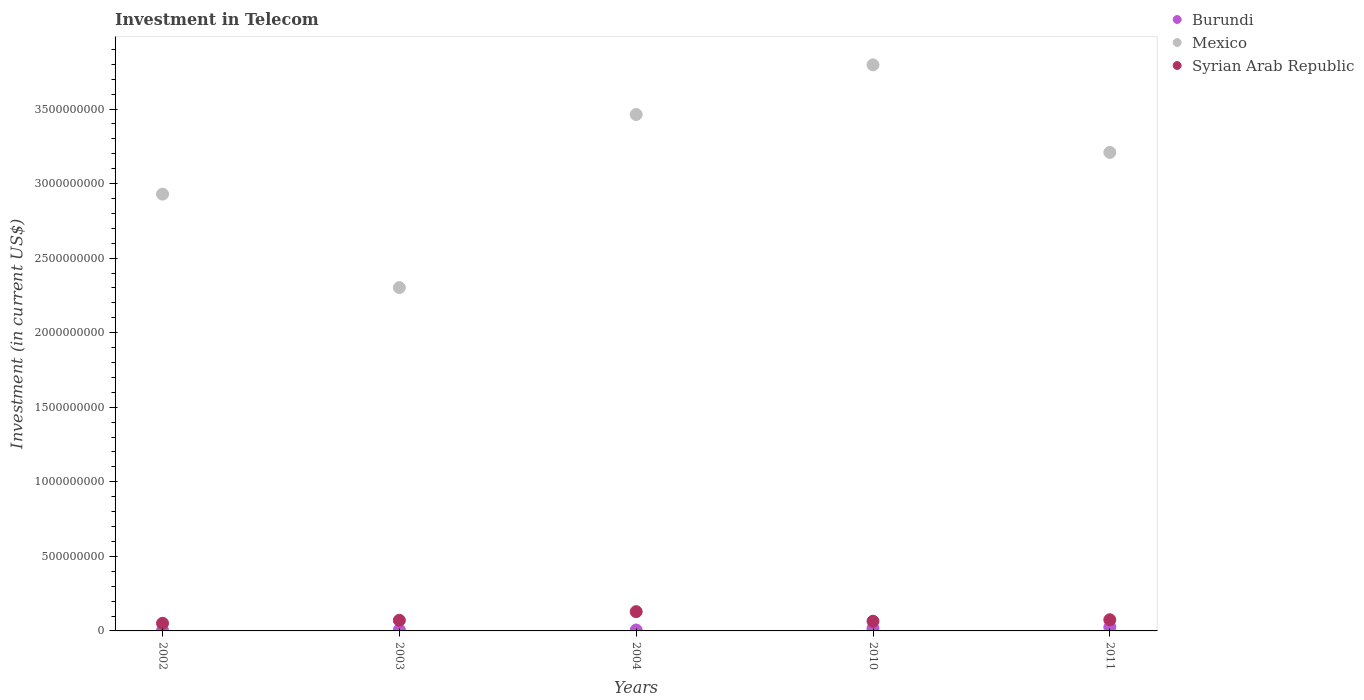Is the number of dotlines equal to the number of legend labels?
Your response must be concise. Yes. What is the amount invested in telecom in Burundi in 2010?
Make the answer very short. 1.70e+07. Across all years, what is the maximum amount invested in telecom in Syrian Arab Republic?
Offer a terse response. 1.29e+08. Across all years, what is the minimum amount invested in telecom in Mexico?
Make the answer very short. 2.30e+09. In which year was the amount invested in telecom in Syrian Arab Republic maximum?
Keep it short and to the point. 2004. In which year was the amount invested in telecom in Mexico minimum?
Offer a very short reply. 2003. What is the total amount invested in telecom in Mexico in the graph?
Make the answer very short. 1.57e+1. What is the difference between the amount invested in telecom in Burundi in 2004 and that in 2011?
Keep it short and to the point. -1.90e+07. What is the difference between the amount invested in telecom in Syrian Arab Republic in 2004 and the amount invested in telecom in Burundi in 2010?
Provide a short and direct response. 1.12e+08. What is the average amount invested in telecom in Syrian Arab Republic per year?
Offer a terse response. 7.84e+07. In the year 2004, what is the difference between the amount invested in telecom in Burundi and amount invested in telecom in Syrian Arab Republic?
Give a very brief answer. -1.23e+08. What is the ratio of the amount invested in telecom in Burundi in 2004 to that in 2010?
Provide a short and direct response. 0.35. Is the amount invested in telecom in Burundi in 2002 less than that in 2011?
Offer a terse response. Yes. What is the difference between the highest and the second highest amount invested in telecom in Burundi?
Your answer should be compact. 8.00e+06. What is the difference between the highest and the lowest amount invested in telecom in Mexico?
Offer a very short reply. 1.49e+09. In how many years, is the amount invested in telecom in Burundi greater than the average amount invested in telecom in Burundi taken over all years?
Offer a terse response. 2. Is the sum of the amount invested in telecom in Syrian Arab Republic in 2002 and 2010 greater than the maximum amount invested in telecom in Burundi across all years?
Your answer should be very brief. Yes. Is it the case that in every year, the sum of the amount invested in telecom in Syrian Arab Republic and amount invested in telecom in Mexico  is greater than the amount invested in telecom in Burundi?
Keep it short and to the point. Yes. Does the amount invested in telecom in Syrian Arab Republic monotonically increase over the years?
Provide a succinct answer. No. Is the amount invested in telecom in Mexico strictly less than the amount invested in telecom in Burundi over the years?
Offer a terse response. No. How many years are there in the graph?
Provide a succinct answer. 5. What is the difference between two consecutive major ticks on the Y-axis?
Offer a terse response. 5.00e+08. Where does the legend appear in the graph?
Ensure brevity in your answer.  Top right. How many legend labels are there?
Make the answer very short. 3. How are the legend labels stacked?
Offer a very short reply. Vertical. What is the title of the graph?
Provide a succinct answer. Investment in Telecom. What is the label or title of the X-axis?
Offer a very short reply. Years. What is the label or title of the Y-axis?
Make the answer very short. Investment (in current US$). What is the Investment (in current US$) of Mexico in 2002?
Your response must be concise. 2.93e+09. What is the Investment (in current US$) of Syrian Arab Republic in 2002?
Provide a succinct answer. 5.12e+07. What is the Investment (in current US$) in Burundi in 2003?
Make the answer very short. 6.00e+06. What is the Investment (in current US$) of Mexico in 2003?
Keep it short and to the point. 2.30e+09. What is the Investment (in current US$) in Syrian Arab Republic in 2003?
Give a very brief answer. 7.12e+07. What is the Investment (in current US$) of Mexico in 2004?
Your response must be concise. 3.46e+09. What is the Investment (in current US$) of Syrian Arab Republic in 2004?
Offer a very short reply. 1.29e+08. What is the Investment (in current US$) of Burundi in 2010?
Offer a very short reply. 1.70e+07. What is the Investment (in current US$) of Mexico in 2010?
Make the answer very short. 3.80e+09. What is the Investment (in current US$) of Syrian Arab Republic in 2010?
Offer a terse response. 6.50e+07. What is the Investment (in current US$) in Burundi in 2011?
Offer a terse response. 2.50e+07. What is the Investment (in current US$) in Mexico in 2011?
Give a very brief answer. 3.21e+09. What is the Investment (in current US$) of Syrian Arab Republic in 2011?
Provide a short and direct response. 7.50e+07. Across all years, what is the maximum Investment (in current US$) in Burundi?
Provide a succinct answer. 2.50e+07. Across all years, what is the maximum Investment (in current US$) of Mexico?
Your answer should be very brief. 3.80e+09. Across all years, what is the maximum Investment (in current US$) in Syrian Arab Republic?
Provide a short and direct response. 1.29e+08. Across all years, what is the minimum Investment (in current US$) of Mexico?
Give a very brief answer. 2.30e+09. Across all years, what is the minimum Investment (in current US$) in Syrian Arab Republic?
Offer a terse response. 5.12e+07. What is the total Investment (in current US$) in Burundi in the graph?
Your answer should be very brief. 5.70e+07. What is the total Investment (in current US$) of Mexico in the graph?
Offer a very short reply. 1.57e+1. What is the total Investment (in current US$) of Syrian Arab Republic in the graph?
Your answer should be compact. 3.92e+08. What is the difference between the Investment (in current US$) in Burundi in 2002 and that in 2003?
Make the answer very short. -3.00e+06. What is the difference between the Investment (in current US$) of Mexico in 2002 and that in 2003?
Offer a very short reply. 6.27e+08. What is the difference between the Investment (in current US$) of Syrian Arab Republic in 2002 and that in 2003?
Offer a very short reply. -2.00e+07. What is the difference between the Investment (in current US$) of Mexico in 2002 and that in 2004?
Make the answer very short. -5.34e+08. What is the difference between the Investment (in current US$) of Syrian Arab Republic in 2002 and that in 2004?
Offer a terse response. -7.80e+07. What is the difference between the Investment (in current US$) of Burundi in 2002 and that in 2010?
Ensure brevity in your answer.  -1.40e+07. What is the difference between the Investment (in current US$) in Mexico in 2002 and that in 2010?
Your response must be concise. -8.67e+08. What is the difference between the Investment (in current US$) in Syrian Arab Republic in 2002 and that in 2010?
Your answer should be compact. -1.38e+07. What is the difference between the Investment (in current US$) in Burundi in 2002 and that in 2011?
Ensure brevity in your answer.  -2.20e+07. What is the difference between the Investment (in current US$) in Mexico in 2002 and that in 2011?
Provide a succinct answer. -2.80e+08. What is the difference between the Investment (in current US$) of Syrian Arab Republic in 2002 and that in 2011?
Your response must be concise. -2.38e+07. What is the difference between the Investment (in current US$) in Burundi in 2003 and that in 2004?
Offer a very short reply. 0. What is the difference between the Investment (in current US$) in Mexico in 2003 and that in 2004?
Provide a succinct answer. -1.16e+09. What is the difference between the Investment (in current US$) in Syrian Arab Republic in 2003 and that in 2004?
Offer a terse response. -5.80e+07. What is the difference between the Investment (in current US$) in Burundi in 2003 and that in 2010?
Provide a short and direct response. -1.10e+07. What is the difference between the Investment (in current US$) of Mexico in 2003 and that in 2010?
Ensure brevity in your answer.  -1.49e+09. What is the difference between the Investment (in current US$) in Syrian Arab Republic in 2003 and that in 2010?
Provide a short and direct response. 6.25e+06. What is the difference between the Investment (in current US$) of Burundi in 2003 and that in 2011?
Your response must be concise. -1.90e+07. What is the difference between the Investment (in current US$) of Mexico in 2003 and that in 2011?
Offer a very short reply. -9.06e+08. What is the difference between the Investment (in current US$) of Syrian Arab Republic in 2003 and that in 2011?
Your answer should be very brief. -3.75e+06. What is the difference between the Investment (in current US$) in Burundi in 2004 and that in 2010?
Offer a very short reply. -1.10e+07. What is the difference between the Investment (in current US$) of Mexico in 2004 and that in 2010?
Your answer should be very brief. -3.33e+08. What is the difference between the Investment (in current US$) in Syrian Arab Republic in 2004 and that in 2010?
Offer a very short reply. 6.42e+07. What is the difference between the Investment (in current US$) of Burundi in 2004 and that in 2011?
Give a very brief answer. -1.90e+07. What is the difference between the Investment (in current US$) of Mexico in 2004 and that in 2011?
Provide a short and direct response. 2.54e+08. What is the difference between the Investment (in current US$) in Syrian Arab Republic in 2004 and that in 2011?
Give a very brief answer. 5.42e+07. What is the difference between the Investment (in current US$) in Burundi in 2010 and that in 2011?
Offer a very short reply. -8.00e+06. What is the difference between the Investment (in current US$) of Mexico in 2010 and that in 2011?
Give a very brief answer. 5.87e+08. What is the difference between the Investment (in current US$) in Syrian Arab Republic in 2010 and that in 2011?
Provide a succinct answer. -1.00e+07. What is the difference between the Investment (in current US$) of Burundi in 2002 and the Investment (in current US$) of Mexico in 2003?
Provide a short and direct response. -2.30e+09. What is the difference between the Investment (in current US$) in Burundi in 2002 and the Investment (in current US$) in Syrian Arab Republic in 2003?
Provide a succinct answer. -6.82e+07. What is the difference between the Investment (in current US$) in Mexico in 2002 and the Investment (in current US$) in Syrian Arab Republic in 2003?
Offer a terse response. 2.86e+09. What is the difference between the Investment (in current US$) of Burundi in 2002 and the Investment (in current US$) of Mexico in 2004?
Provide a succinct answer. -3.46e+09. What is the difference between the Investment (in current US$) in Burundi in 2002 and the Investment (in current US$) in Syrian Arab Republic in 2004?
Give a very brief answer. -1.26e+08. What is the difference between the Investment (in current US$) in Mexico in 2002 and the Investment (in current US$) in Syrian Arab Republic in 2004?
Ensure brevity in your answer.  2.80e+09. What is the difference between the Investment (in current US$) of Burundi in 2002 and the Investment (in current US$) of Mexico in 2010?
Your answer should be compact. -3.79e+09. What is the difference between the Investment (in current US$) in Burundi in 2002 and the Investment (in current US$) in Syrian Arab Republic in 2010?
Keep it short and to the point. -6.20e+07. What is the difference between the Investment (in current US$) of Mexico in 2002 and the Investment (in current US$) of Syrian Arab Republic in 2010?
Your answer should be compact. 2.86e+09. What is the difference between the Investment (in current US$) of Burundi in 2002 and the Investment (in current US$) of Mexico in 2011?
Keep it short and to the point. -3.21e+09. What is the difference between the Investment (in current US$) of Burundi in 2002 and the Investment (in current US$) of Syrian Arab Republic in 2011?
Offer a terse response. -7.20e+07. What is the difference between the Investment (in current US$) in Mexico in 2002 and the Investment (in current US$) in Syrian Arab Republic in 2011?
Offer a terse response. 2.85e+09. What is the difference between the Investment (in current US$) of Burundi in 2003 and the Investment (in current US$) of Mexico in 2004?
Make the answer very short. -3.46e+09. What is the difference between the Investment (in current US$) in Burundi in 2003 and the Investment (in current US$) in Syrian Arab Republic in 2004?
Offer a very short reply. -1.23e+08. What is the difference between the Investment (in current US$) of Mexico in 2003 and the Investment (in current US$) of Syrian Arab Republic in 2004?
Your answer should be compact. 2.17e+09. What is the difference between the Investment (in current US$) of Burundi in 2003 and the Investment (in current US$) of Mexico in 2010?
Your answer should be very brief. -3.79e+09. What is the difference between the Investment (in current US$) in Burundi in 2003 and the Investment (in current US$) in Syrian Arab Republic in 2010?
Your answer should be very brief. -5.90e+07. What is the difference between the Investment (in current US$) of Mexico in 2003 and the Investment (in current US$) of Syrian Arab Republic in 2010?
Offer a terse response. 2.24e+09. What is the difference between the Investment (in current US$) of Burundi in 2003 and the Investment (in current US$) of Mexico in 2011?
Offer a very short reply. -3.20e+09. What is the difference between the Investment (in current US$) in Burundi in 2003 and the Investment (in current US$) in Syrian Arab Republic in 2011?
Keep it short and to the point. -6.90e+07. What is the difference between the Investment (in current US$) of Mexico in 2003 and the Investment (in current US$) of Syrian Arab Republic in 2011?
Your answer should be compact. 2.23e+09. What is the difference between the Investment (in current US$) in Burundi in 2004 and the Investment (in current US$) in Mexico in 2010?
Keep it short and to the point. -3.79e+09. What is the difference between the Investment (in current US$) of Burundi in 2004 and the Investment (in current US$) of Syrian Arab Republic in 2010?
Your answer should be compact. -5.90e+07. What is the difference between the Investment (in current US$) in Mexico in 2004 and the Investment (in current US$) in Syrian Arab Republic in 2010?
Your answer should be very brief. 3.40e+09. What is the difference between the Investment (in current US$) in Burundi in 2004 and the Investment (in current US$) in Mexico in 2011?
Provide a succinct answer. -3.20e+09. What is the difference between the Investment (in current US$) of Burundi in 2004 and the Investment (in current US$) of Syrian Arab Republic in 2011?
Ensure brevity in your answer.  -6.90e+07. What is the difference between the Investment (in current US$) in Mexico in 2004 and the Investment (in current US$) in Syrian Arab Republic in 2011?
Give a very brief answer. 3.39e+09. What is the difference between the Investment (in current US$) of Burundi in 2010 and the Investment (in current US$) of Mexico in 2011?
Make the answer very short. -3.19e+09. What is the difference between the Investment (in current US$) of Burundi in 2010 and the Investment (in current US$) of Syrian Arab Republic in 2011?
Provide a short and direct response. -5.80e+07. What is the difference between the Investment (in current US$) of Mexico in 2010 and the Investment (in current US$) of Syrian Arab Republic in 2011?
Offer a very short reply. 3.72e+09. What is the average Investment (in current US$) in Burundi per year?
Your answer should be very brief. 1.14e+07. What is the average Investment (in current US$) of Mexico per year?
Your answer should be very brief. 3.14e+09. What is the average Investment (in current US$) in Syrian Arab Republic per year?
Offer a terse response. 7.84e+07. In the year 2002, what is the difference between the Investment (in current US$) of Burundi and Investment (in current US$) of Mexico?
Offer a terse response. -2.93e+09. In the year 2002, what is the difference between the Investment (in current US$) of Burundi and Investment (in current US$) of Syrian Arab Republic?
Provide a short and direct response. -4.82e+07. In the year 2002, what is the difference between the Investment (in current US$) of Mexico and Investment (in current US$) of Syrian Arab Republic?
Keep it short and to the point. 2.88e+09. In the year 2003, what is the difference between the Investment (in current US$) of Burundi and Investment (in current US$) of Mexico?
Ensure brevity in your answer.  -2.30e+09. In the year 2003, what is the difference between the Investment (in current US$) in Burundi and Investment (in current US$) in Syrian Arab Republic?
Provide a succinct answer. -6.52e+07. In the year 2003, what is the difference between the Investment (in current US$) of Mexico and Investment (in current US$) of Syrian Arab Republic?
Your answer should be compact. 2.23e+09. In the year 2004, what is the difference between the Investment (in current US$) in Burundi and Investment (in current US$) in Mexico?
Provide a succinct answer. -3.46e+09. In the year 2004, what is the difference between the Investment (in current US$) of Burundi and Investment (in current US$) of Syrian Arab Republic?
Keep it short and to the point. -1.23e+08. In the year 2004, what is the difference between the Investment (in current US$) of Mexico and Investment (in current US$) of Syrian Arab Republic?
Ensure brevity in your answer.  3.33e+09. In the year 2010, what is the difference between the Investment (in current US$) in Burundi and Investment (in current US$) in Mexico?
Make the answer very short. -3.78e+09. In the year 2010, what is the difference between the Investment (in current US$) in Burundi and Investment (in current US$) in Syrian Arab Republic?
Ensure brevity in your answer.  -4.80e+07. In the year 2010, what is the difference between the Investment (in current US$) in Mexico and Investment (in current US$) in Syrian Arab Republic?
Make the answer very short. 3.73e+09. In the year 2011, what is the difference between the Investment (in current US$) of Burundi and Investment (in current US$) of Mexico?
Your answer should be compact. -3.18e+09. In the year 2011, what is the difference between the Investment (in current US$) in Burundi and Investment (in current US$) in Syrian Arab Republic?
Keep it short and to the point. -5.00e+07. In the year 2011, what is the difference between the Investment (in current US$) in Mexico and Investment (in current US$) in Syrian Arab Republic?
Provide a short and direct response. 3.13e+09. What is the ratio of the Investment (in current US$) in Burundi in 2002 to that in 2003?
Make the answer very short. 0.5. What is the ratio of the Investment (in current US$) of Mexico in 2002 to that in 2003?
Give a very brief answer. 1.27. What is the ratio of the Investment (in current US$) in Syrian Arab Republic in 2002 to that in 2003?
Provide a succinct answer. 0.72. What is the ratio of the Investment (in current US$) of Mexico in 2002 to that in 2004?
Your response must be concise. 0.85. What is the ratio of the Investment (in current US$) of Syrian Arab Republic in 2002 to that in 2004?
Keep it short and to the point. 0.4. What is the ratio of the Investment (in current US$) of Burundi in 2002 to that in 2010?
Make the answer very short. 0.18. What is the ratio of the Investment (in current US$) in Mexico in 2002 to that in 2010?
Make the answer very short. 0.77. What is the ratio of the Investment (in current US$) in Syrian Arab Republic in 2002 to that in 2010?
Your answer should be very brief. 0.79. What is the ratio of the Investment (in current US$) of Burundi in 2002 to that in 2011?
Keep it short and to the point. 0.12. What is the ratio of the Investment (in current US$) of Mexico in 2002 to that in 2011?
Keep it short and to the point. 0.91. What is the ratio of the Investment (in current US$) of Syrian Arab Republic in 2002 to that in 2011?
Give a very brief answer. 0.68. What is the ratio of the Investment (in current US$) in Burundi in 2003 to that in 2004?
Provide a succinct answer. 1. What is the ratio of the Investment (in current US$) in Mexico in 2003 to that in 2004?
Your answer should be very brief. 0.66. What is the ratio of the Investment (in current US$) of Syrian Arab Republic in 2003 to that in 2004?
Ensure brevity in your answer.  0.55. What is the ratio of the Investment (in current US$) of Burundi in 2003 to that in 2010?
Provide a short and direct response. 0.35. What is the ratio of the Investment (in current US$) in Mexico in 2003 to that in 2010?
Ensure brevity in your answer.  0.61. What is the ratio of the Investment (in current US$) of Syrian Arab Republic in 2003 to that in 2010?
Your answer should be compact. 1.1. What is the ratio of the Investment (in current US$) in Burundi in 2003 to that in 2011?
Your answer should be compact. 0.24. What is the ratio of the Investment (in current US$) of Mexico in 2003 to that in 2011?
Provide a succinct answer. 0.72. What is the ratio of the Investment (in current US$) in Syrian Arab Republic in 2003 to that in 2011?
Your response must be concise. 0.95. What is the ratio of the Investment (in current US$) of Burundi in 2004 to that in 2010?
Offer a terse response. 0.35. What is the ratio of the Investment (in current US$) of Mexico in 2004 to that in 2010?
Offer a very short reply. 0.91. What is the ratio of the Investment (in current US$) in Syrian Arab Republic in 2004 to that in 2010?
Your answer should be compact. 1.99. What is the ratio of the Investment (in current US$) in Burundi in 2004 to that in 2011?
Make the answer very short. 0.24. What is the ratio of the Investment (in current US$) of Mexico in 2004 to that in 2011?
Give a very brief answer. 1.08. What is the ratio of the Investment (in current US$) of Syrian Arab Republic in 2004 to that in 2011?
Provide a short and direct response. 1.72. What is the ratio of the Investment (in current US$) of Burundi in 2010 to that in 2011?
Give a very brief answer. 0.68. What is the ratio of the Investment (in current US$) of Mexico in 2010 to that in 2011?
Offer a terse response. 1.18. What is the ratio of the Investment (in current US$) in Syrian Arab Republic in 2010 to that in 2011?
Offer a terse response. 0.87. What is the difference between the highest and the second highest Investment (in current US$) in Burundi?
Your answer should be compact. 8.00e+06. What is the difference between the highest and the second highest Investment (in current US$) of Mexico?
Keep it short and to the point. 3.33e+08. What is the difference between the highest and the second highest Investment (in current US$) of Syrian Arab Republic?
Offer a very short reply. 5.42e+07. What is the difference between the highest and the lowest Investment (in current US$) of Burundi?
Ensure brevity in your answer.  2.20e+07. What is the difference between the highest and the lowest Investment (in current US$) in Mexico?
Ensure brevity in your answer.  1.49e+09. What is the difference between the highest and the lowest Investment (in current US$) of Syrian Arab Republic?
Offer a very short reply. 7.80e+07. 